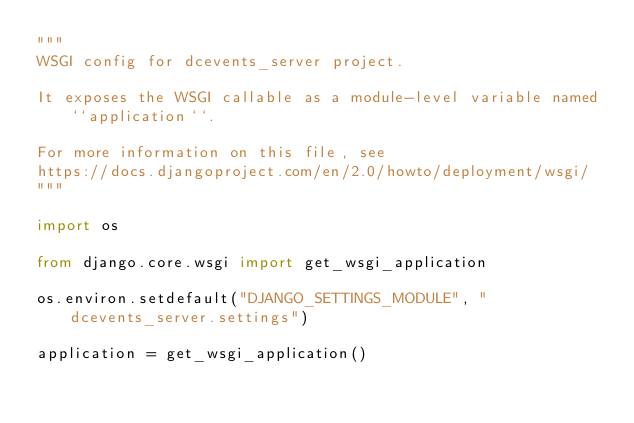Convert code to text. <code><loc_0><loc_0><loc_500><loc_500><_Python_>"""
WSGI config for dcevents_server project.

It exposes the WSGI callable as a module-level variable named ``application``.

For more information on this file, see
https://docs.djangoproject.com/en/2.0/howto/deployment/wsgi/
"""

import os

from django.core.wsgi import get_wsgi_application

os.environ.setdefault("DJANGO_SETTINGS_MODULE", "dcevents_server.settings")

application = get_wsgi_application()
</code> 